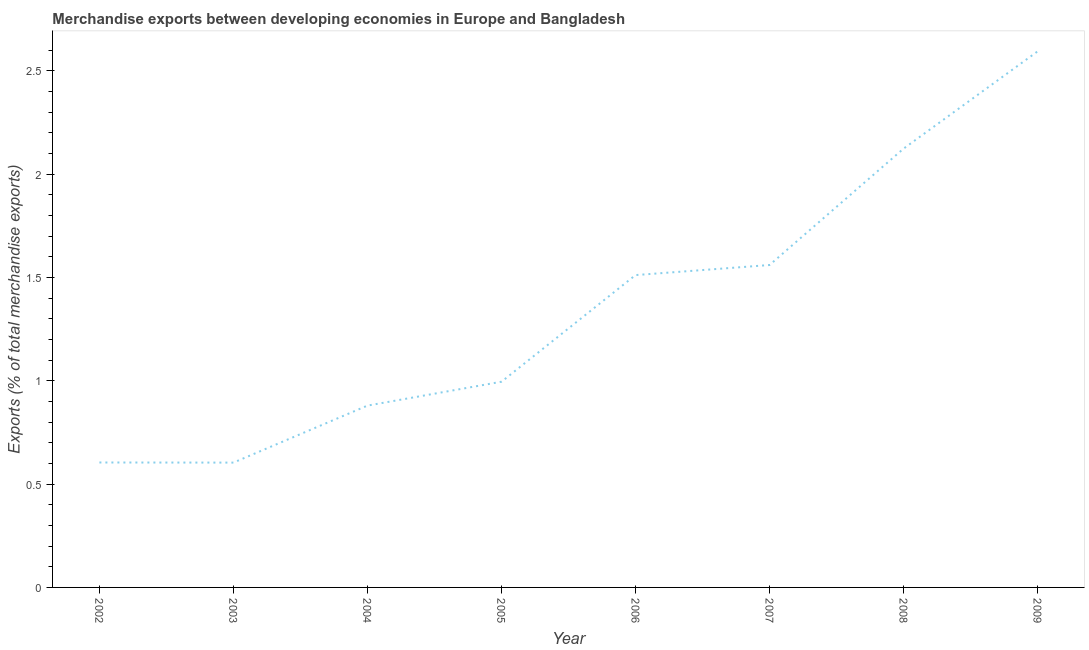What is the merchandise exports in 2004?
Offer a terse response. 0.88. Across all years, what is the maximum merchandise exports?
Provide a short and direct response. 2.59. Across all years, what is the minimum merchandise exports?
Your answer should be very brief. 0.6. In which year was the merchandise exports maximum?
Provide a succinct answer. 2009. What is the sum of the merchandise exports?
Make the answer very short. 10.88. What is the difference between the merchandise exports in 2007 and 2009?
Your response must be concise. -1.03. What is the average merchandise exports per year?
Provide a succinct answer. 1.36. What is the median merchandise exports?
Your answer should be very brief. 1.25. Do a majority of the years between 2002 and 2005 (inclusive) have merchandise exports greater than 0.30000000000000004 %?
Provide a succinct answer. Yes. What is the ratio of the merchandise exports in 2002 to that in 2009?
Keep it short and to the point. 0.23. Is the difference between the merchandise exports in 2005 and 2007 greater than the difference between any two years?
Ensure brevity in your answer.  No. What is the difference between the highest and the second highest merchandise exports?
Provide a succinct answer. 0.47. What is the difference between the highest and the lowest merchandise exports?
Offer a very short reply. 1.99. In how many years, is the merchandise exports greater than the average merchandise exports taken over all years?
Your answer should be compact. 4. How many lines are there?
Give a very brief answer. 1. How many years are there in the graph?
Make the answer very short. 8. What is the difference between two consecutive major ticks on the Y-axis?
Your response must be concise. 0.5. Are the values on the major ticks of Y-axis written in scientific E-notation?
Provide a short and direct response. No. Does the graph contain any zero values?
Provide a short and direct response. No. What is the title of the graph?
Offer a terse response. Merchandise exports between developing economies in Europe and Bangladesh. What is the label or title of the Y-axis?
Provide a succinct answer. Exports (% of total merchandise exports). What is the Exports (% of total merchandise exports) of 2002?
Provide a short and direct response. 0.6. What is the Exports (% of total merchandise exports) of 2003?
Offer a terse response. 0.6. What is the Exports (% of total merchandise exports) of 2004?
Make the answer very short. 0.88. What is the Exports (% of total merchandise exports) in 2005?
Offer a very short reply. 1. What is the Exports (% of total merchandise exports) of 2006?
Ensure brevity in your answer.  1.51. What is the Exports (% of total merchandise exports) of 2007?
Keep it short and to the point. 1.56. What is the Exports (% of total merchandise exports) in 2008?
Your response must be concise. 2.12. What is the Exports (% of total merchandise exports) of 2009?
Provide a short and direct response. 2.59. What is the difference between the Exports (% of total merchandise exports) in 2002 and 2003?
Provide a succinct answer. 0. What is the difference between the Exports (% of total merchandise exports) in 2002 and 2004?
Make the answer very short. -0.28. What is the difference between the Exports (% of total merchandise exports) in 2002 and 2005?
Your response must be concise. -0.39. What is the difference between the Exports (% of total merchandise exports) in 2002 and 2006?
Your response must be concise. -0.91. What is the difference between the Exports (% of total merchandise exports) in 2002 and 2007?
Your response must be concise. -0.96. What is the difference between the Exports (% of total merchandise exports) in 2002 and 2008?
Your answer should be very brief. -1.52. What is the difference between the Exports (% of total merchandise exports) in 2002 and 2009?
Ensure brevity in your answer.  -1.99. What is the difference between the Exports (% of total merchandise exports) in 2003 and 2004?
Keep it short and to the point. -0.28. What is the difference between the Exports (% of total merchandise exports) in 2003 and 2005?
Your answer should be very brief. -0.39. What is the difference between the Exports (% of total merchandise exports) in 2003 and 2006?
Offer a terse response. -0.91. What is the difference between the Exports (% of total merchandise exports) in 2003 and 2007?
Provide a succinct answer. -0.96. What is the difference between the Exports (% of total merchandise exports) in 2003 and 2008?
Your answer should be compact. -1.52. What is the difference between the Exports (% of total merchandise exports) in 2003 and 2009?
Your response must be concise. -1.99. What is the difference between the Exports (% of total merchandise exports) in 2004 and 2005?
Ensure brevity in your answer.  -0.12. What is the difference between the Exports (% of total merchandise exports) in 2004 and 2006?
Provide a short and direct response. -0.63. What is the difference between the Exports (% of total merchandise exports) in 2004 and 2007?
Give a very brief answer. -0.68. What is the difference between the Exports (% of total merchandise exports) in 2004 and 2008?
Provide a short and direct response. -1.24. What is the difference between the Exports (% of total merchandise exports) in 2004 and 2009?
Provide a short and direct response. -1.71. What is the difference between the Exports (% of total merchandise exports) in 2005 and 2006?
Give a very brief answer. -0.52. What is the difference between the Exports (% of total merchandise exports) in 2005 and 2007?
Provide a succinct answer. -0.56. What is the difference between the Exports (% of total merchandise exports) in 2005 and 2008?
Offer a terse response. -1.13. What is the difference between the Exports (% of total merchandise exports) in 2005 and 2009?
Make the answer very short. -1.6. What is the difference between the Exports (% of total merchandise exports) in 2006 and 2007?
Offer a very short reply. -0.05. What is the difference between the Exports (% of total merchandise exports) in 2006 and 2008?
Offer a very short reply. -0.61. What is the difference between the Exports (% of total merchandise exports) in 2006 and 2009?
Offer a very short reply. -1.08. What is the difference between the Exports (% of total merchandise exports) in 2007 and 2008?
Ensure brevity in your answer.  -0.56. What is the difference between the Exports (% of total merchandise exports) in 2007 and 2009?
Ensure brevity in your answer.  -1.03. What is the difference between the Exports (% of total merchandise exports) in 2008 and 2009?
Offer a terse response. -0.47. What is the ratio of the Exports (% of total merchandise exports) in 2002 to that in 2003?
Make the answer very short. 1. What is the ratio of the Exports (% of total merchandise exports) in 2002 to that in 2004?
Give a very brief answer. 0.69. What is the ratio of the Exports (% of total merchandise exports) in 2002 to that in 2005?
Your answer should be compact. 0.61. What is the ratio of the Exports (% of total merchandise exports) in 2002 to that in 2007?
Offer a terse response. 0.39. What is the ratio of the Exports (% of total merchandise exports) in 2002 to that in 2008?
Make the answer very short. 0.28. What is the ratio of the Exports (% of total merchandise exports) in 2002 to that in 2009?
Your answer should be very brief. 0.23. What is the ratio of the Exports (% of total merchandise exports) in 2003 to that in 2004?
Ensure brevity in your answer.  0.69. What is the ratio of the Exports (% of total merchandise exports) in 2003 to that in 2005?
Your answer should be compact. 0.61. What is the ratio of the Exports (% of total merchandise exports) in 2003 to that in 2007?
Your answer should be very brief. 0.39. What is the ratio of the Exports (% of total merchandise exports) in 2003 to that in 2008?
Provide a succinct answer. 0.28. What is the ratio of the Exports (% of total merchandise exports) in 2003 to that in 2009?
Provide a succinct answer. 0.23. What is the ratio of the Exports (% of total merchandise exports) in 2004 to that in 2005?
Offer a terse response. 0.88. What is the ratio of the Exports (% of total merchandise exports) in 2004 to that in 2006?
Provide a succinct answer. 0.58. What is the ratio of the Exports (% of total merchandise exports) in 2004 to that in 2007?
Your answer should be compact. 0.56. What is the ratio of the Exports (% of total merchandise exports) in 2004 to that in 2008?
Your answer should be compact. 0.41. What is the ratio of the Exports (% of total merchandise exports) in 2004 to that in 2009?
Provide a succinct answer. 0.34. What is the ratio of the Exports (% of total merchandise exports) in 2005 to that in 2006?
Offer a terse response. 0.66. What is the ratio of the Exports (% of total merchandise exports) in 2005 to that in 2007?
Keep it short and to the point. 0.64. What is the ratio of the Exports (% of total merchandise exports) in 2005 to that in 2008?
Your response must be concise. 0.47. What is the ratio of the Exports (% of total merchandise exports) in 2005 to that in 2009?
Provide a succinct answer. 0.38. What is the ratio of the Exports (% of total merchandise exports) in 2006 to that in 2008?
Ensure brevity in your answer.  0.71. What is the ratio of the Exports (% of total merchandise exports) in 2006 to that in 2009?
Provide a short and direct response. 0.58. What is the ratio of the Exports (% of total merchandise exports) in 2007 to that in 2008?
Keep it short and to the point. 0.73. What is the ratio of the Exports (% of total merchandise exports) in 2007 to that in 2009?
Offer a terse response. 0.6. What is the ratio of the Exports (% of total merchandise exports) in 2008 to that in 2009?
Ensure brevity in your answer.  0.82. 